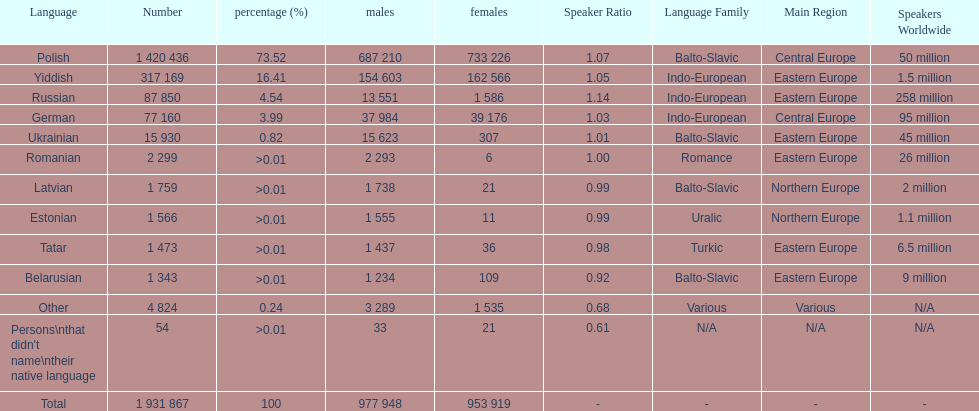Which language had the most number of people speaking it. Polish. 